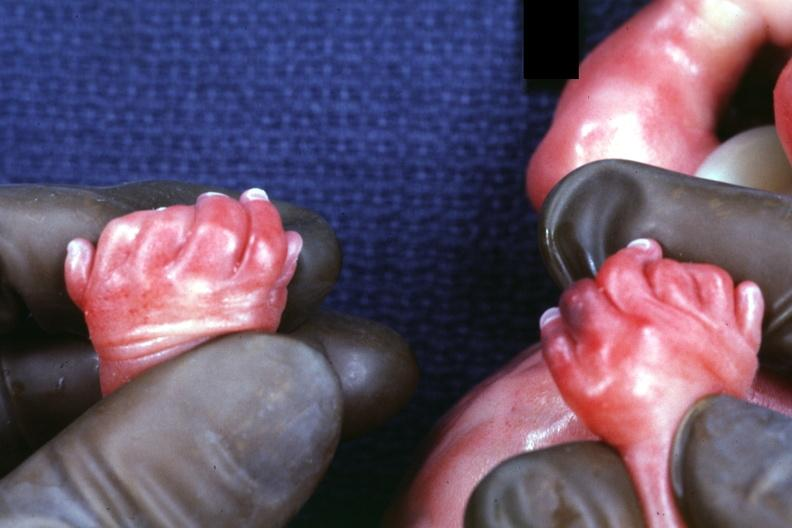what has polycystic disease?
Answer the question using a single word or phrase. Child 